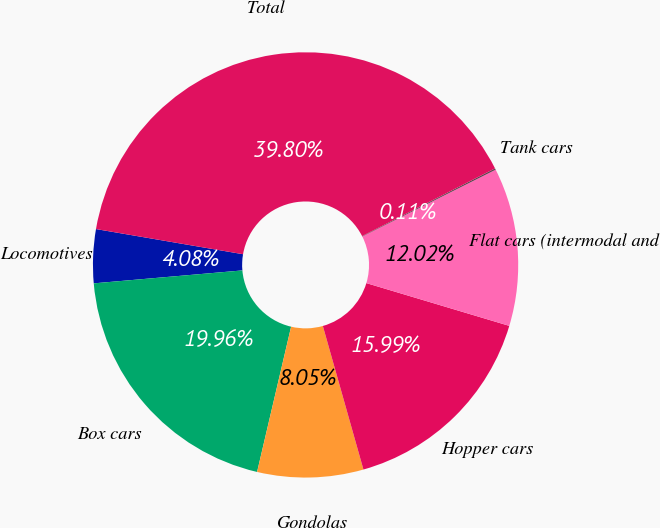Convert chart. <chart><loc_0><loc_0><loc_500><loc_500><pie_chart><fcel>Locomotives<fcel>Box cars<fcel>Gondolas<fcel>Hopper cars<fcel>Flat cars (intermodal and<fcel>Tank cars<fcel>Total<nl><fcel>4.08%<fcel>19.96%<fcel>8.05%<fcel>15.99%<fcel>12.02%<fcel>0.11%<fcel>39.81%<nl></chart> 